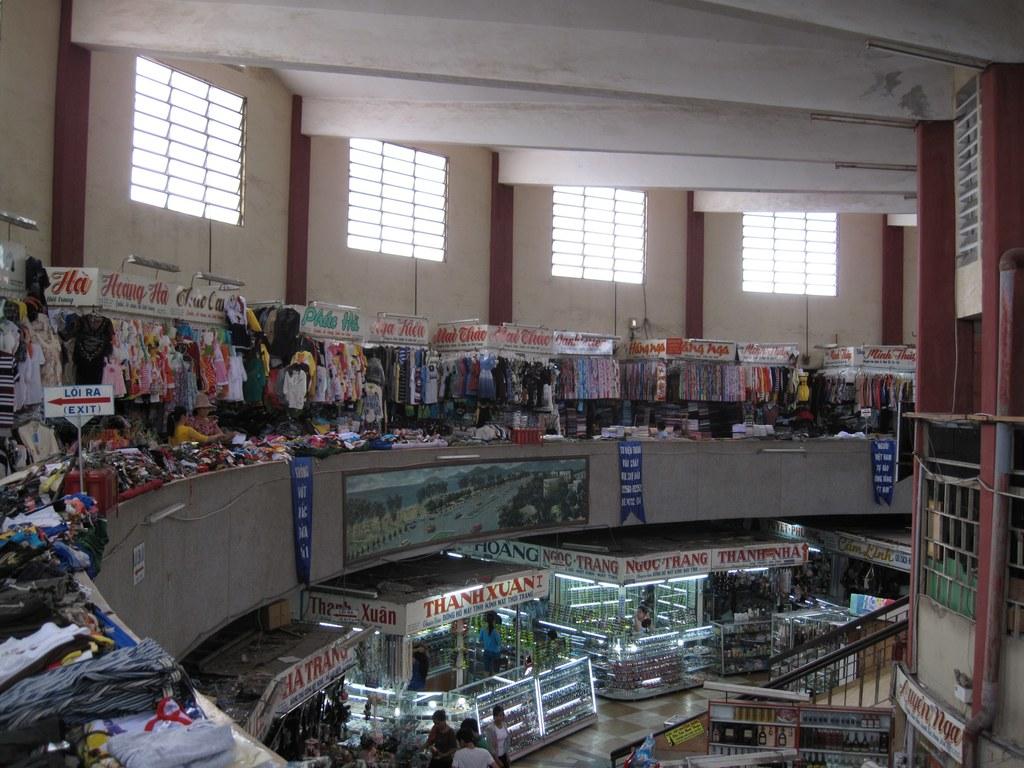Is that an exit sign in upper left ?
Offer a terse response. Yes. 